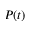<formula> <loc_0><loc_0><loc_500><loc_500>P ( t )</formula> 